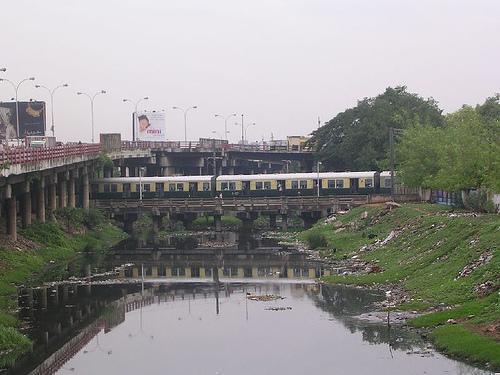How many train cars are shown?
Give a very brief answer. 3. 